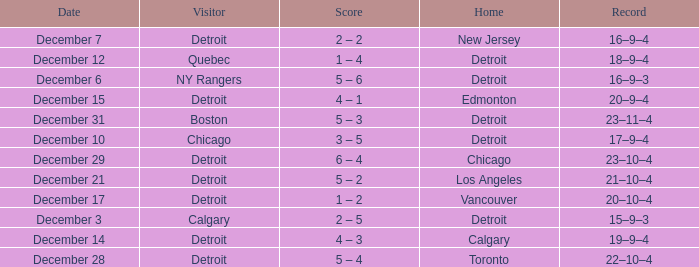Who is the visitor on the date december 31? Boston. 